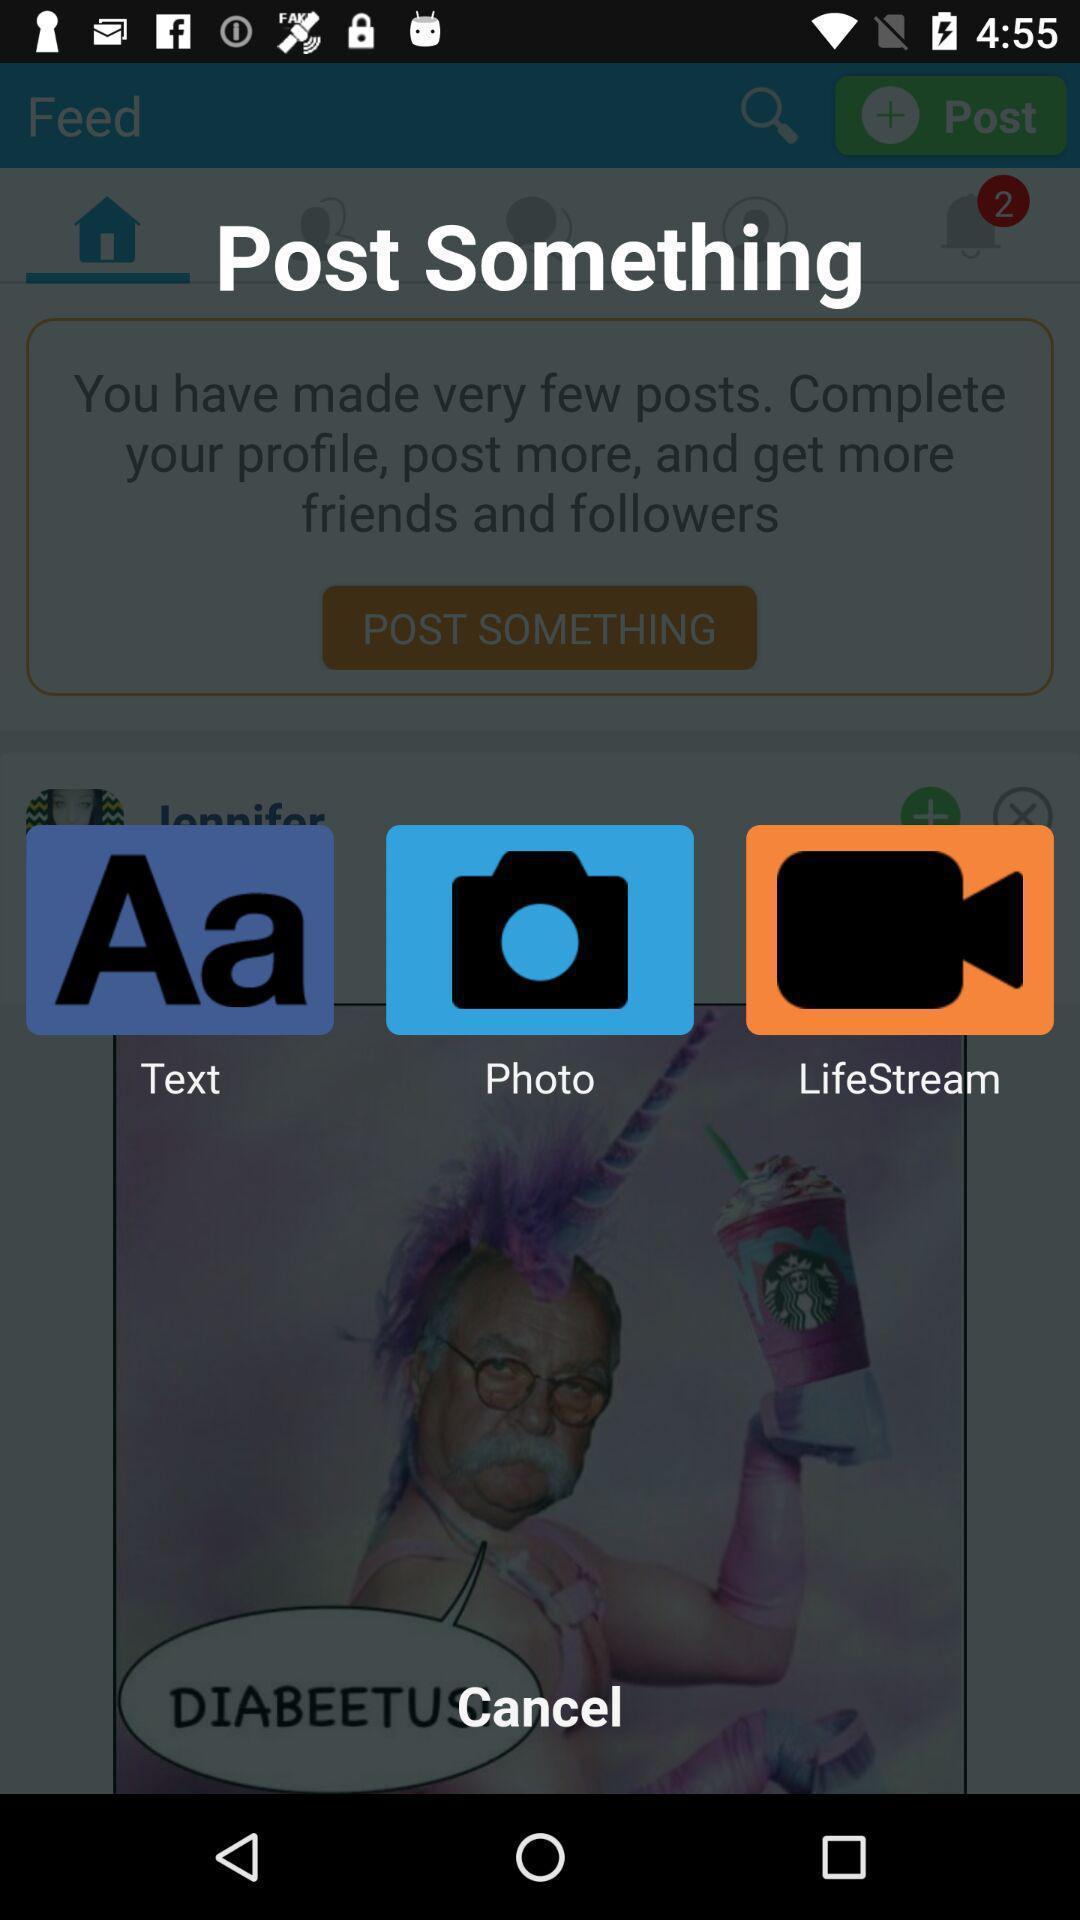Explain what's happening in this screen capture. Screen displaying options to post something. 